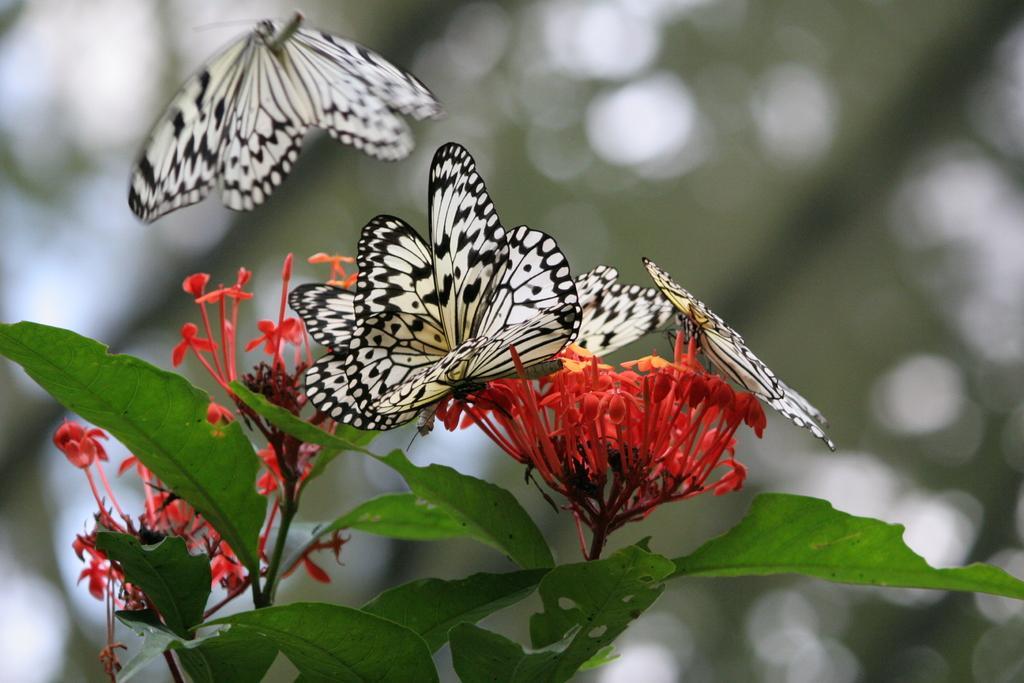Please provide a concise description of this image. In this picture I can see there are few butterflies on the flower and there is another flower flying here. There are few leaves and the backdrop is blurred. 